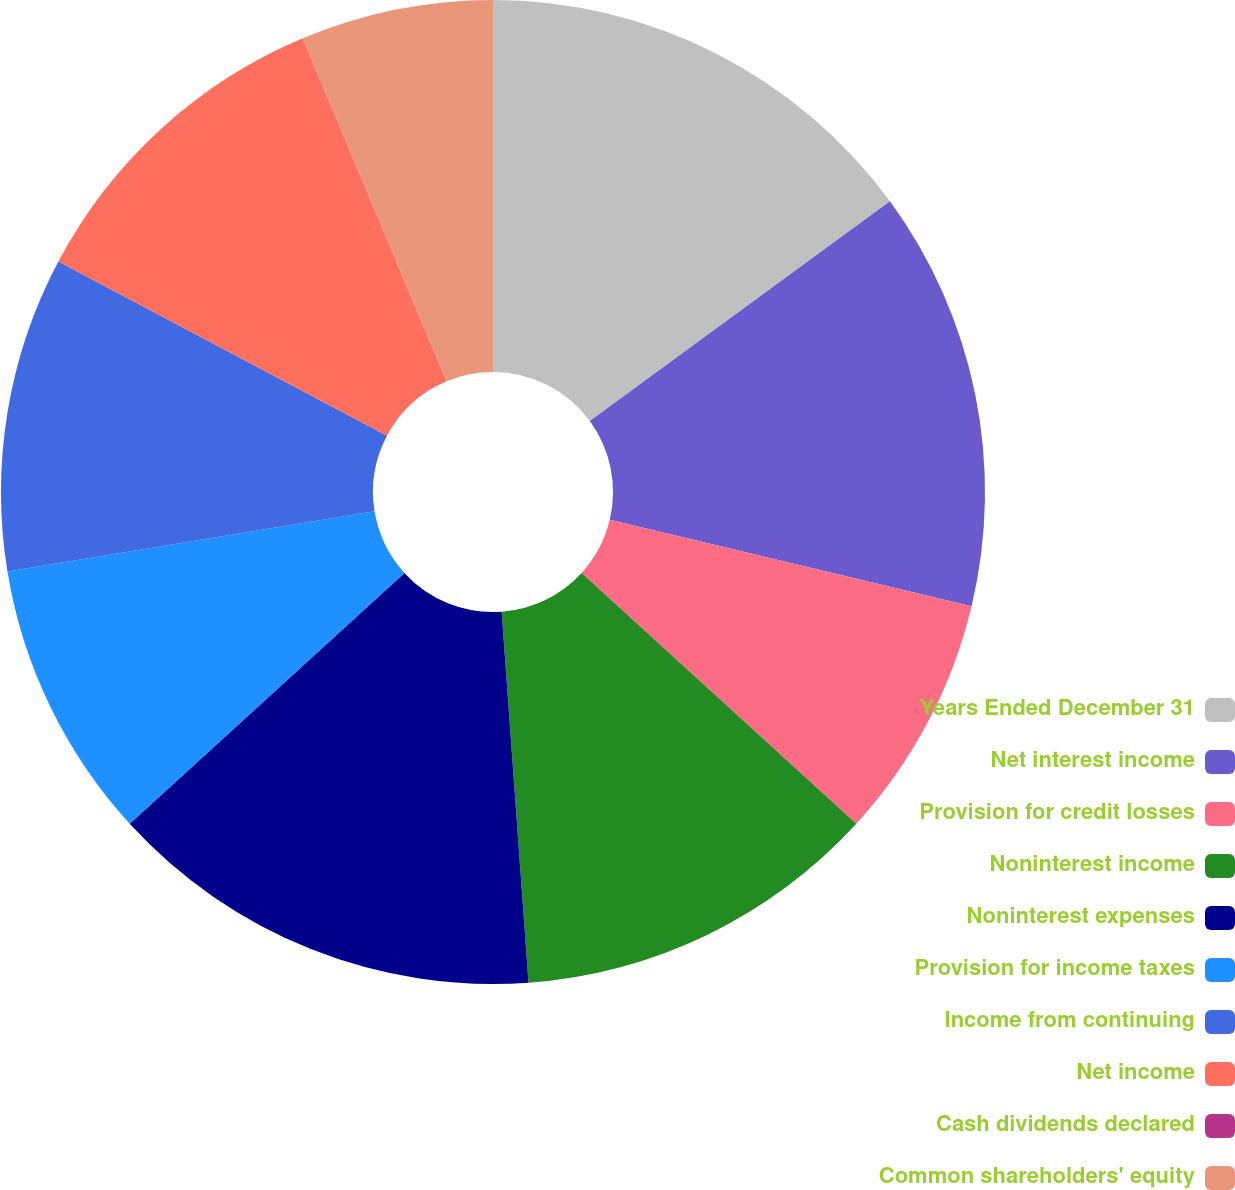<chart> <loc_0><loc_0><loc_500><loc_500><pie_chart><fcel>Years Ended December 31<fcel>Net interest income<fcel>Provision for credit losses<fcel>Noninterest income<fcel>Noninterest expenses<fcel>Provision for income taxes<fcel>Income from continuing<fcel>Net income<fcel>Cash dividends declared<fcel>Common shareholders' equity<nl><fcel>14.94%<fcel>13.79%<fcel>8.05%<fcel>12.07%<fcel>14.37%<fcel>9.2%<fcel>10.34%<fcel>10.92%<fcel>0.0%<fcel>6.32%<nl></chart> 